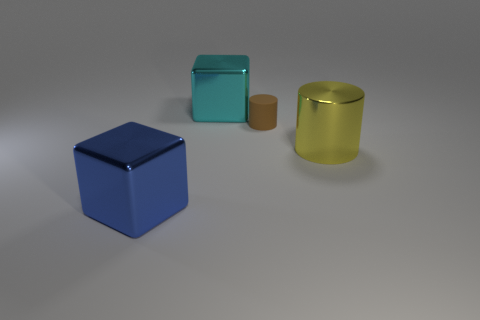Add 3 small cylinders. How many objects exist? 7 Add 1 small cylinders. How many small cylinders are left? 2 Add 2 big cyan metal objects. How many big cyan metal objects exist? 3 Subtract 1 blue cubes. How many objects are left? 3 Subtract all small green matte cylinders. Subtract all large metal blocks. How many objects are left? 2 